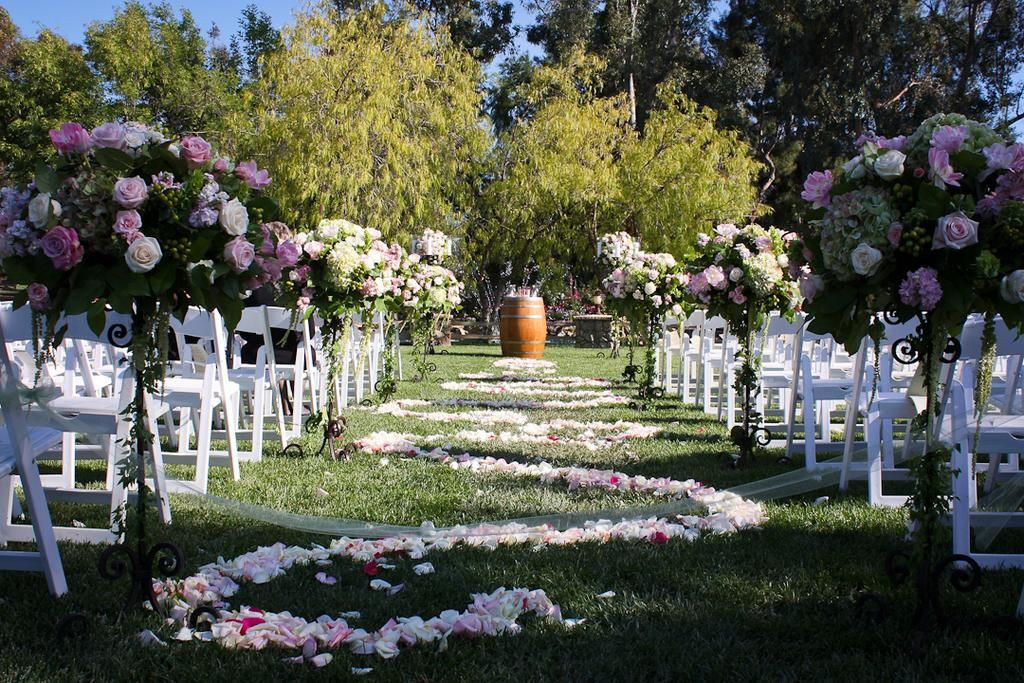What type of terrain is visible in the image? There is a grassy land in the image. What type of furniture can be seen in the image? There are chairs in the image. What type of plants are present in the image? There are flower plants and trees in the image. What historical event is being commemorated by the thing in the image? There is no specific historical event or thing mentioned in the image, as it primarily features grassy land, chairs, flower plants, and trees. 